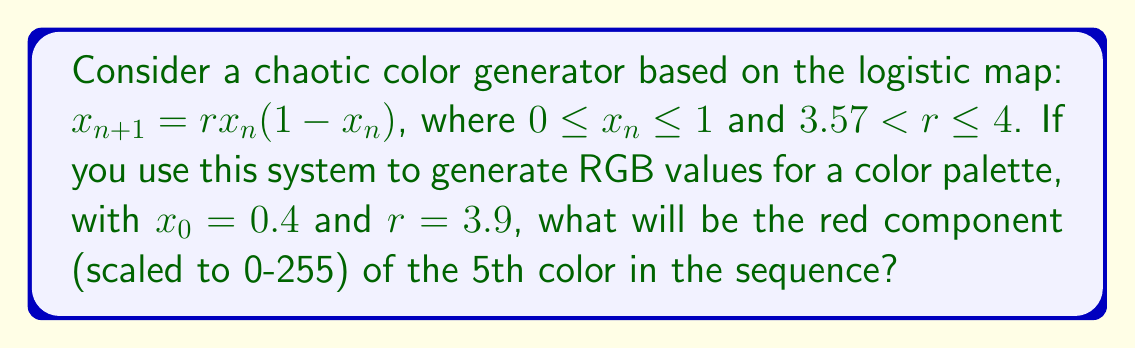Provide a solution to this math problem. Let's approach this step-by-step:

1) The logistic map is given by: $x_{n+1} = rx_n(1-x_n)$

2) We're given $x_0 = 0.4$ and $r = 3.9$

3) Let's calculate the first 5 iterations:

   $x_1 = 3.9 \cdot 0.4 \cdot (1-0.4) = 0.936$
   
   $x_2 = 3.9 \cdot 0.936 \cdot (1-0.936) = 0.234$
   
   $x_3 = 3.9 \cdot 0.234 \cdot (1-0.234) = 0.700$
   
   $x_4 = 3.9 \cdot 0.700 \cdot (1-0.700) = 0.819$
   
   $x_5 = 3.9 \cdot 0.819 \cdot (1-0.819) = 0.579$

4) The 5th color in the sequence corresponds to $x_5 = 0.579$

5) To scale this to the 0-255 range for RGB values, we multiply by 255:

   $0.579 \cdot 255 = 147.645$

6) Rounding to the nearest integer gives us 148.
Answer: 148 